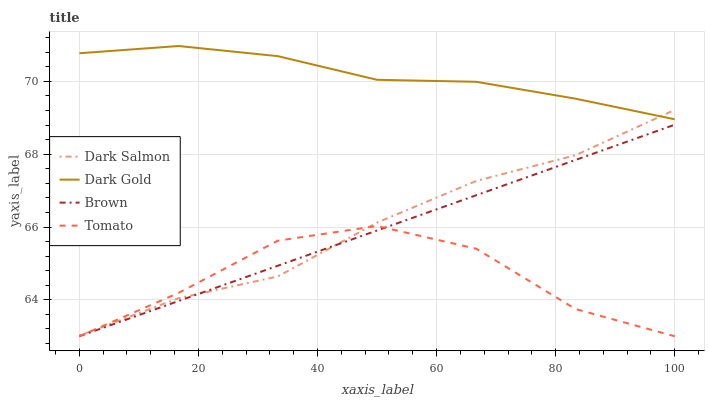Does Brown have the minimum area under the curve?
Answer yes or no. No. Does Brown have the maximum area under the curve?
Answer yes or no. No. Is Dark Salmon the smoothest?
Answer yes or no. No. Is Dark Salmon the roughest?
Answer yes or no. No. Does Dark Salmon have the lowest value?
Answer yes or no. No. Does Brown have the highest value?
Answer yes or no. No. Is Tomato less than Dark Gold?
Answer yes or no. Yes. Is Dark Gold greater than Brown?
Answer yes or no. Yes. Does Tomato intersect Dark Gold?
Answer yes or no. No. 